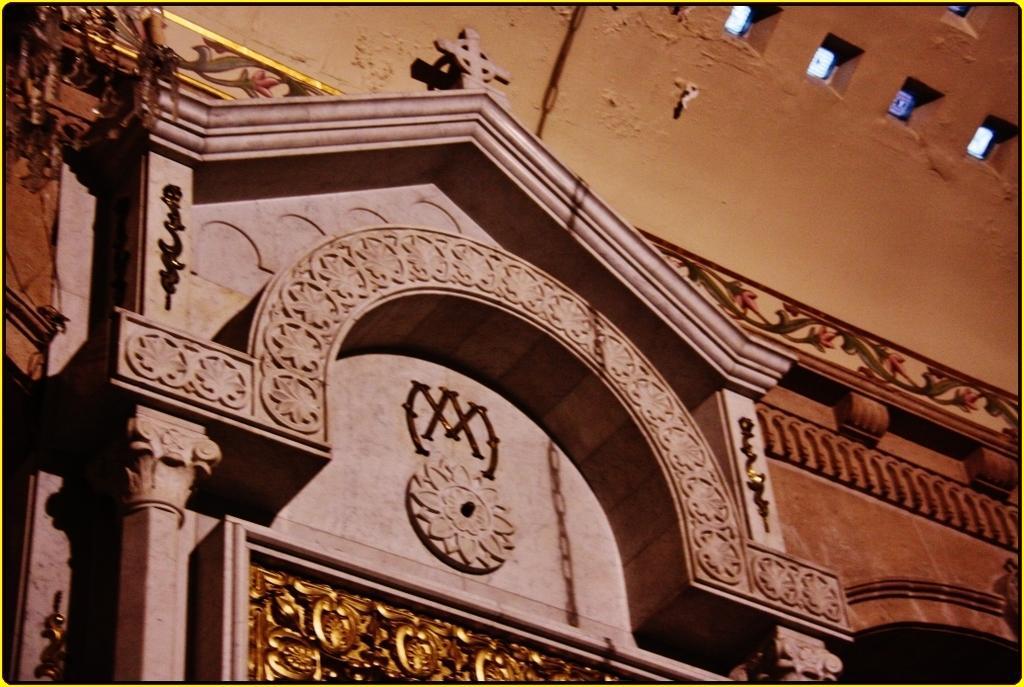How would you summarize this image in a sentence or two? In this image I can see the building which is cream, orange and black in color and to the bottom of the image I can see the gold colored object and to the top of the image I can see few white colored objects. 